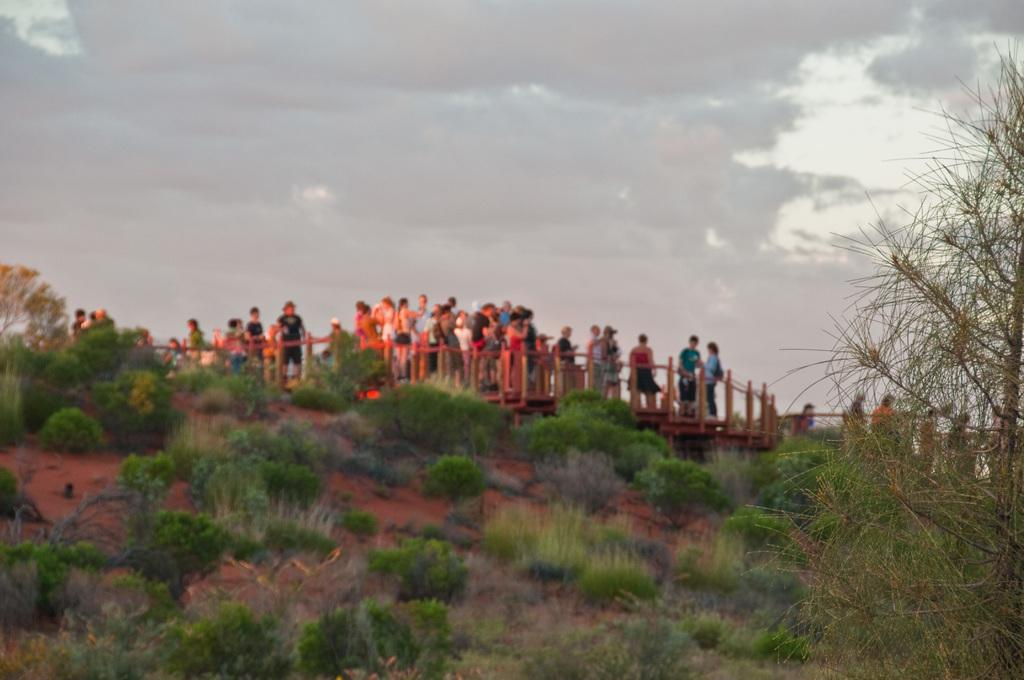What is located in front of the image? There are plants in front of the image. What can be seen in the center of the image? There are people standing on a wooden bridge in the center of the image. What is visible in the background of the image? The sky and trees are visible in the background of the image. What type of jam is being spread on the wooden bridge in the image? There is no jam present in the image; it features people standing on a wooden bridge. Is there a scarf visible on any of the people in the image? The provided facts do not mention any scarves, so we cannot determine if there is one present in the image. 